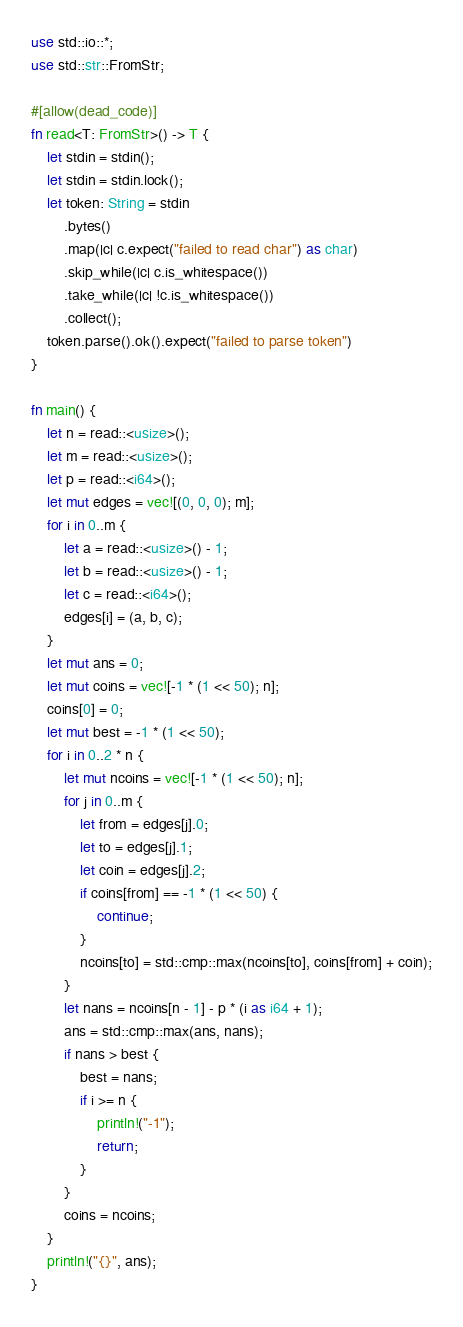<code> <loc_0><loc_0><loc_500><loc_500><_Rust_>use std::io::*;
use std::str::FromStr;

#[allow(dead_code)]
fn read<T: FromStr>() -> T {
    let stdin = stdin();
    let stdin = stdin.lock();
    let token: String = stdin
        .bytes()
        .map(|c| c.expect("failed to read char") as char)
        .skip_while(|c| c.is_whitespace())
        .take_while(|c| !c.is_whitespace())
        .collect();
    token.parse().ok().expect("failed to parse token")
}

fn main() {
    let n = read::<usize>();
    let m = read::<usize>();
    let p = read::<i64>();
    let mut edges = vec![(0, 0, 0); m];
    for i in 0..m {
        let a = read::<usize>() - 1;
        let b = read::<usize>() - 1;
        let c = read::<i64>();
        edges[i] = (a, b, c);
    }
    let mut ans = 0;
    let mut coins = vec![-1 * (1 << 50); n];
    coins[0] = 0;
    let mut best = -1 * (1 << 50);
    for i in 0..2 * n {
        let mut ncoins = vec![-1 * (1 << 50); n];
        for j in 0..m {
            let from = edges[j].0;
            let to = edges[j].1;
            let coin = edges[j].2;
            if coins[from] == -1 * (1 << 50) {
                continue;
            }
            ncoins[to] = std::cmp::max(ncoins[to], coins[from] + coin);
        }
        let nans = ncoins[n - 1] - p * (i as i64 + 1);
        ans = std::cmp::max(ans, nans);
        if nans > best {
            best = nans;
            if i >= n {
                println!("-1");
                return;
            }
        }
        coins = ncoins;
    }
    println!("{}", ans);
}
</code> 